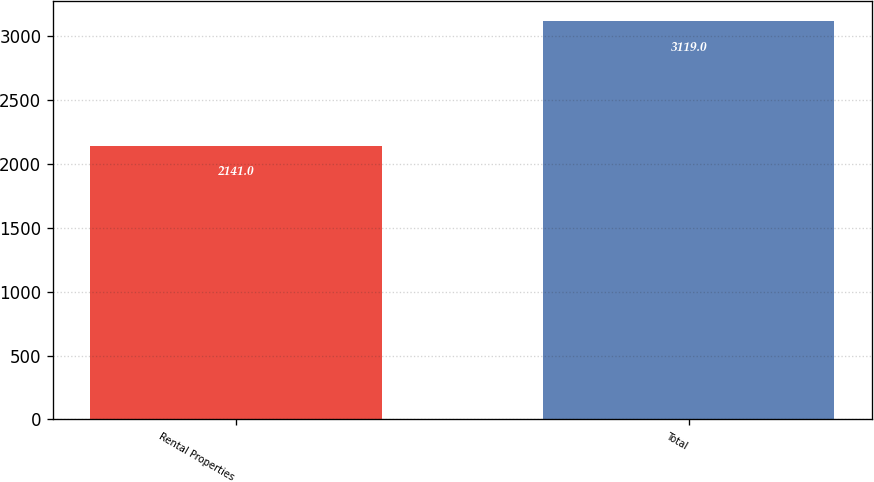<chart> <loc_0><loc_0><loc_500><loc_500><bar_chart><fcel>Rental Properties<fcel>Total<nl><fcel>2141<fcel>3119<nl></chart> 